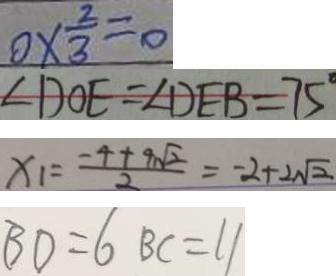<formula> <loc_0><loc_0><loc_500><loc_500>0 \times \frac { 2 } { 3 } = 0 
 \angle D O E = \angle D E B = 7 5 ^ { \circ } 
 x _ { 1 } = \frac { - 4 + 9 \sqrt { 2 } } { 2 } = - 2 + 2 \sqrt { 2 } 
 B D = 6 B C = 1 1</formula> 